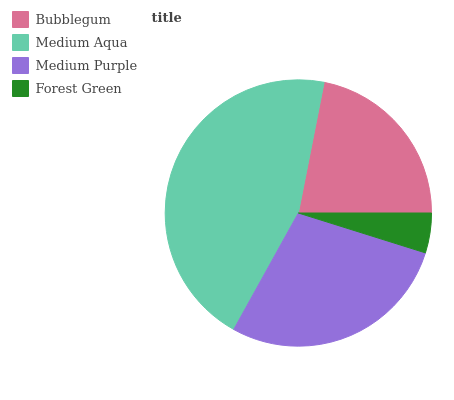Is Forest Green the minimum?
Answer yes or no. Yes. Is Medium Aqua the maximum?
Answer yes or no. Yes. Is Medium Purple the minimum?
Answer yes or no. No. Is Medium Purple the maximum?
Answer yes or no. No. Is Medium Aqua greater than Medium Purple?
Answer yes or no. Yes. Is Medium Purple less than Medium Aqua?
Answer yes or no. Yes. Is Medium Purple greater than Medium Aqua?
Answer yes or no. No. Is Medium Aqua less than Medium Purple?
Answer yes or no. No. Is Medium Purple the high median?
Answer yes or no. Yes. Is Bubblegum the low median?
Answer yes or no. Yes. Is Medium Aqua the high median?
Answer yes or no. No. Is Forest Green the low median?
Answer yes or no. No. 